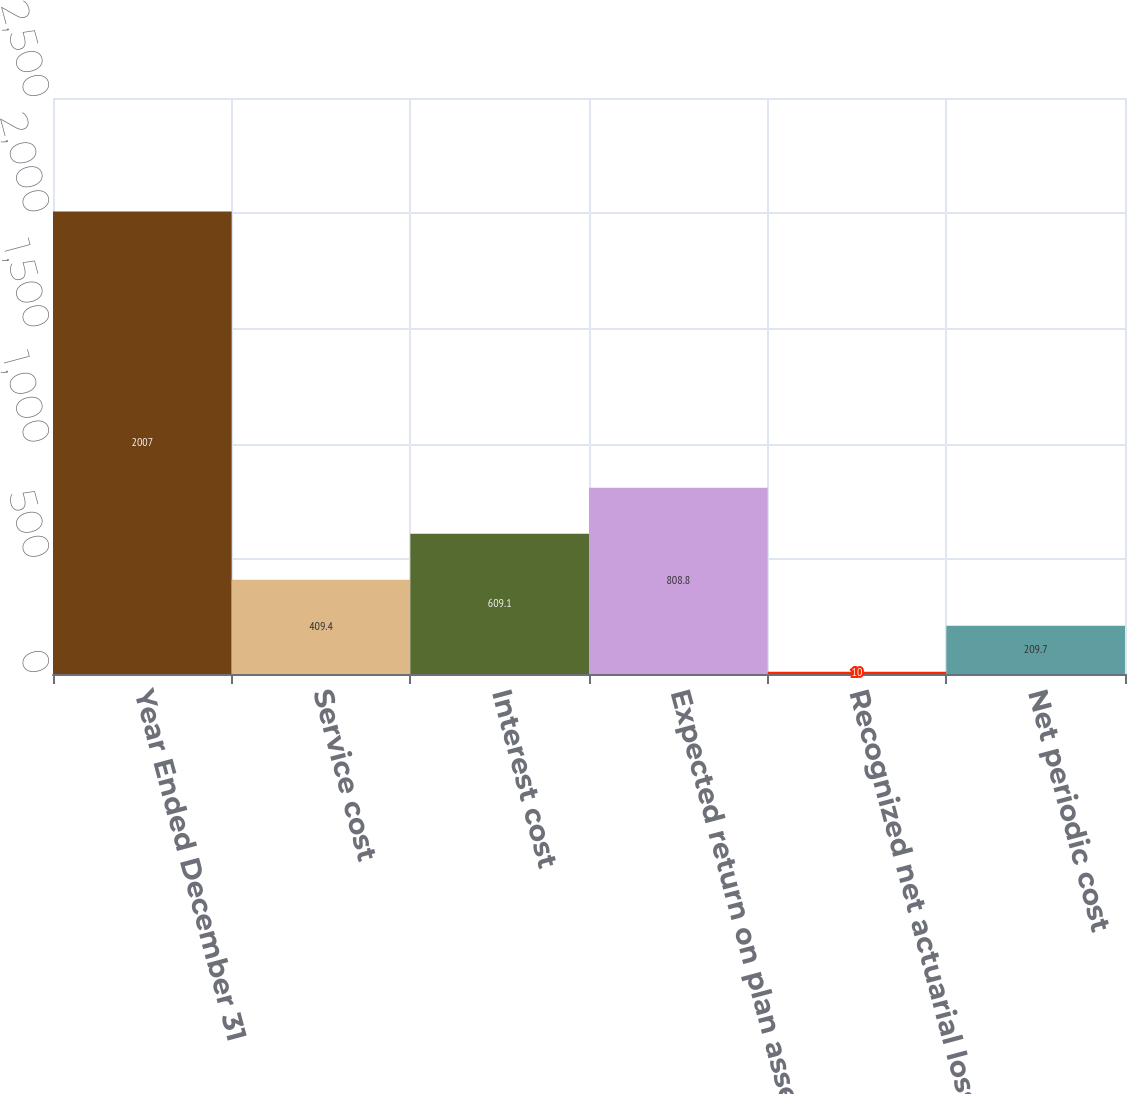Convert chart to OTSL. <chart><loc_0><loc_0><loc_500><loc_500><bar_chart><fcel>Year Ended December 31<fcel>Service cost<fcel>Interest cost<fcel>Expected return on plan assets<fcel>Recognized net actuarial loss<fcel>Net periodic cost<nl><fcel>2007<fcel>409.4<fcel>609.1<fcel>808.8<fcel>10<fcel>209.7<nl></chart> 